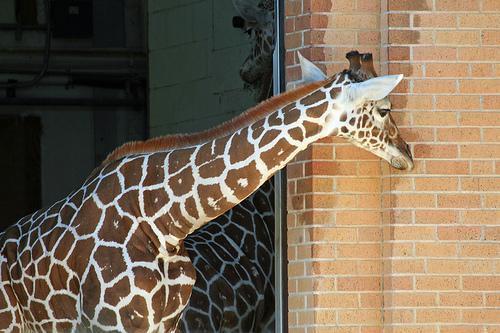How many giraffes are in the photo?
Give a very brief answer. 2. 